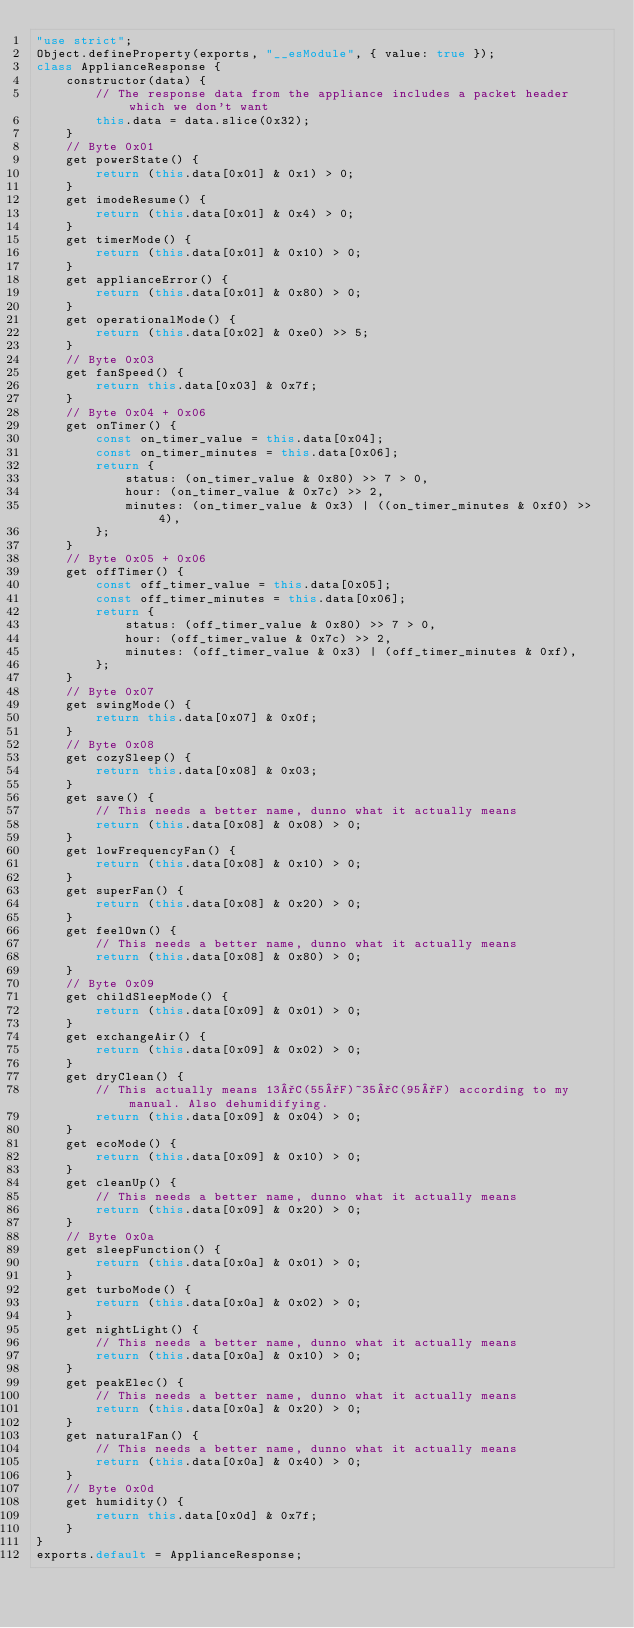Convert code to text. <code><loc_0><loc_0><loc_500><loc_500><_JavaScript_>"use strict";
Object.defineProperty(exports, "__esModule", { value: true });
class ApplianceResponse {
    constructor(data) {
        // The response data from the appliance includes a packet header which we don't want
        this.data = data.slice(0x32);
    }
    // Byte 0x01
    get powerState() {
        return (this.data[0x01] & 0x1) > 0;
    }
    get imodeResume() {
        return (this.data[0x01] & 0x4) > 0;
    }
    get timerMode() {
        return (this.data[0x01] & 0x10) > 0;
    }
    get applianceError() {
        return (this.data[0x01] & 0x80) > 0;
    }
    get operationalMode() {
        return (this.data[0x02] & 0xe0) >> 5;
    }
    // Byte 0x03
    get fanSpeed() {
        return this.data[0x03] & 0x7f;
    }
    // Byte 0x04 + 0x06
    get onTimer() {
        const on_timer_value = this.data[0x04];
        const on_timer_minutes = this.data[0x06];
        return {
            status: (on_timer_value & 0x80) >> 7 > 0,
            hour: (on_timer_value & 0x7c) >> 2,
            minutes: (on_timer_value & 0x3) | ((on_timer_minutes & 0xf0) >> 4),
        };
    }
    // Byte 0x05 + 0x06
    get offTimer() {
        const off_timer_value = this.data[0x05];
        const off_timer_minutes = this.data[0x06];
        return {
            status: (off_timer_value & 0x80) >> 7 > 0,
            hour: (off_timer_value & 0x7c) >> 2,
            minutes: (off_timer_value & 0x3) | (off_timer_minutes & 0xf),
        };
    }
    // Byte 0x07
    get swingMode() {
        return this.data[0x07] & 0x0f;
    }
    // Byte 0x08
    get cozySleep() {
        return this.data[0x08] & 0x03;
    }
    get save() {
        // This needs a better name, dunno what it actually means
        return (this.data[0x08] & 0x08) > 0;
    }
    get lowFrequencyFan() {
        return (this.data[0x08] & 0x10) > 0;
    }
    get superFan() {
        return (this.data[0x08] & 0x20) > 0;
    }
    get feelOwn() {
        // This needs a better name, dunno what it actually means
        return (this.data[0x08] & 0x80) > 0;
    }
    // Byte 0x09
    get childSleepMode() {
        return (this.data[0x09] & 0x01) > 0;
    }
    get exchangeAir() {
        return (this.data[0x09] & 0x02) > 0;
    }
    get dryClean() {
        // This actually means 13°C(55°F)~35°C(95°F) according to my manual. Also dehumidifying.
        return (this.data[0x09] & 0x04) > 0;
    }
    get ecoMode() {
        return (this.data[0x09] & 0x10) > 0;
    }
    get cleanUp() {
        // This needs a better name, dunno what it actually means
        return (this.data[0x09] & 0x20) > 0;
    }
    // Byte 0x0a
    get sleepFunction() {
        return (this.data[0x0a] & 0x01) > 0;
    }
    get turboMode() {
        return (this.data[0x0a] & 0x02) > 0;
    }
    get nightLight() {
        // This needs a better name, dunno what it actually means
        return (this.data[0x0a] & 0x10) > 0;
    }
    get peakElec() {
        // This needs a better name, dunno what it actually means
        return (this.data[0x0a] & 0x20) > 0;
    }
    get naturalFan() {
        // This needs a better name, dunno what it actually means
        return (this.data[0x0a] & 0x40) > 0;
    }
    // Byte 0x0d
    get humidity() {
        return this.data[0x0d] & 0x7f;
    }
}
exports.default = ApplianceResponse;
</code> 